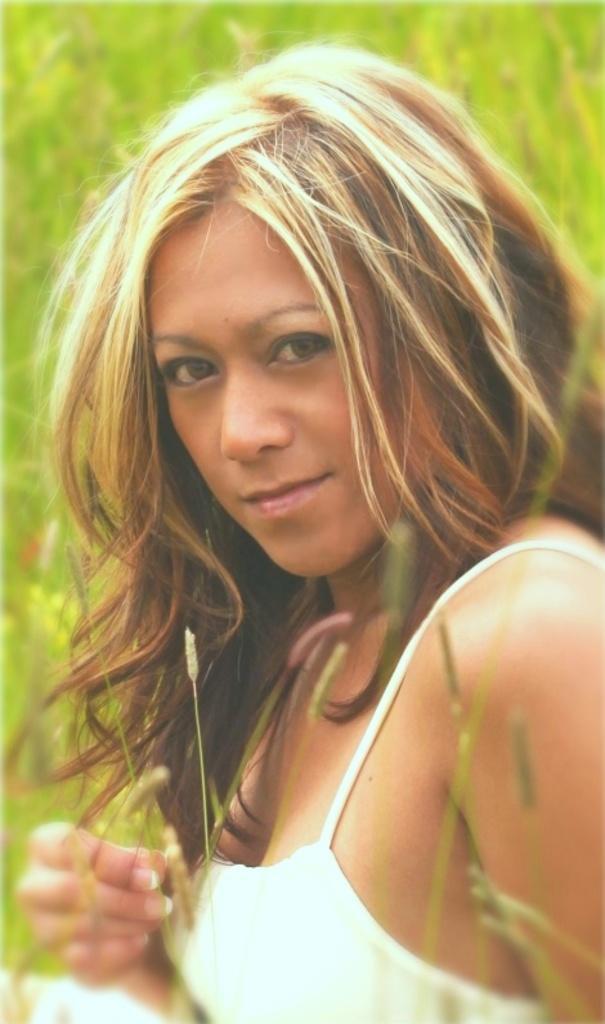Can you describe this image briefly? In this image I see a woman, who is wearing white top and it is green color in the background. 